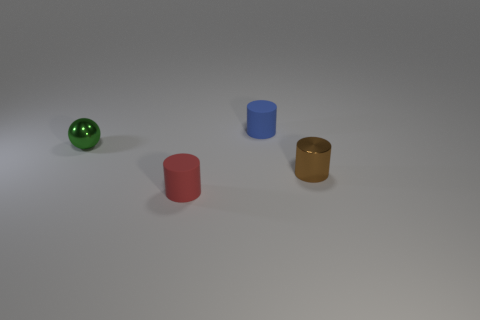Can you estimate the sizes of the objects in comparison to each other? While it's difficult to ascertain the precise sizes without a reference object, we can make some educated guesses based on their relative proportions in the image. The cylinders, which appear identical in height, might be around twice the height of their diameter. The blue cylinder seems to be the smallest in terms of diameter, followed by the red and gold cylinders, which are similar in size. The green sphere is the largest object in the scene, with a diameter that's possibly a bit less than the height of the cylinders. 